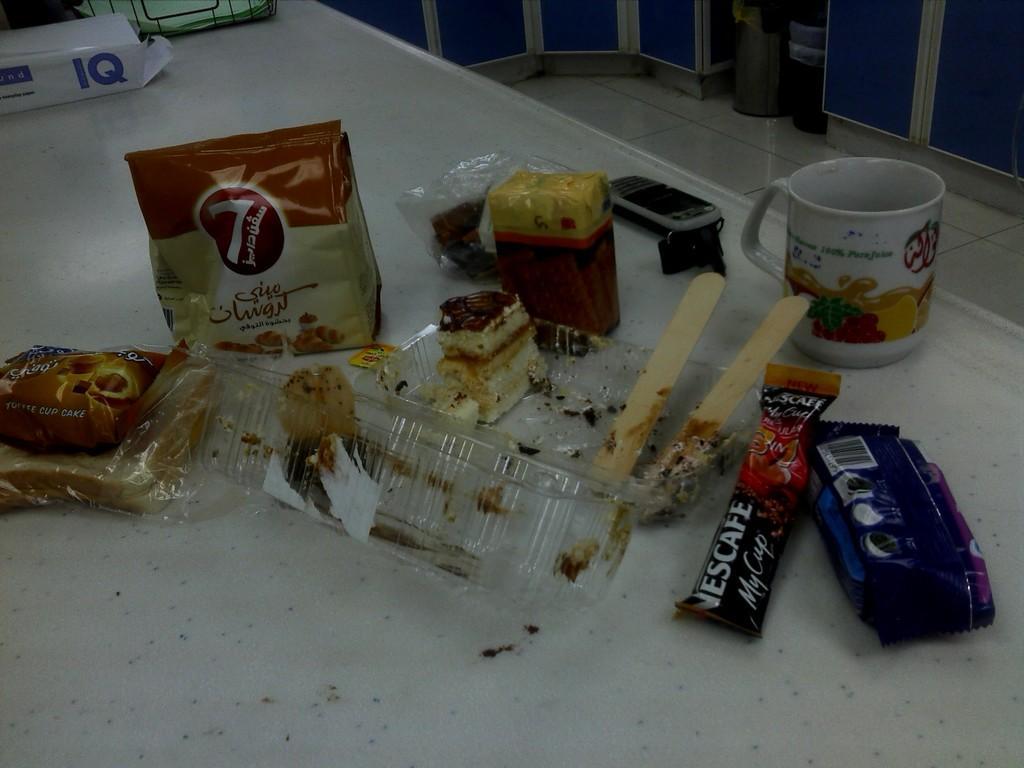Describe this image in one or two sentences. In the center of the image a table is present. On the table we can see a cup, mobile, keys, cake, sticks, chocolate, biscuit and some objects are present. At the top of the image cupboards are there. In the middle of the image floor is present. 